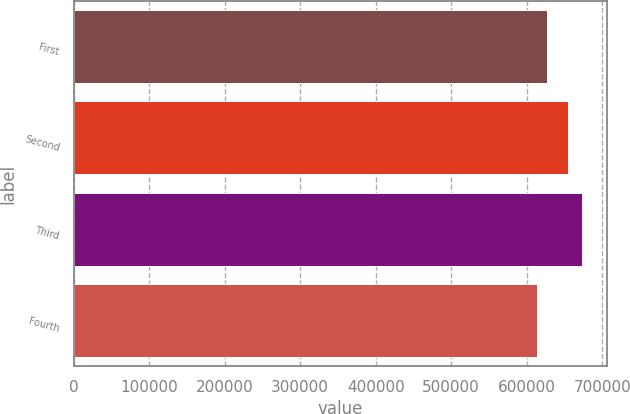Convert chart to OTSL. <chart><loc_0><loc_0><loc_500><loc_500><bar_chart><fcel>First<fcel>Second<fcel>Third<fcel>Fourth<nl><fcel>627159<fcel>654568<fcel>672608<fcel>613809<nl></chart> 